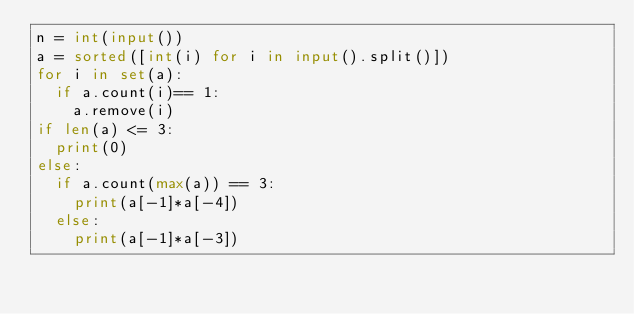<code> <loc_0><loc_0><loc_500><loc_500><_Python_>n = int(input())
a = sorted([int(i) for i in input().split()])
for i in set(a):
  if a.count(i)== 1:
    a.remove(i)
if len(a) <= 3:
  print(0)
else:
  if a.count(max(a)) == 3:
    print(a[-1]*a[-4])
  else:
    print(a[-1]*a[-3])
  
    </code> 